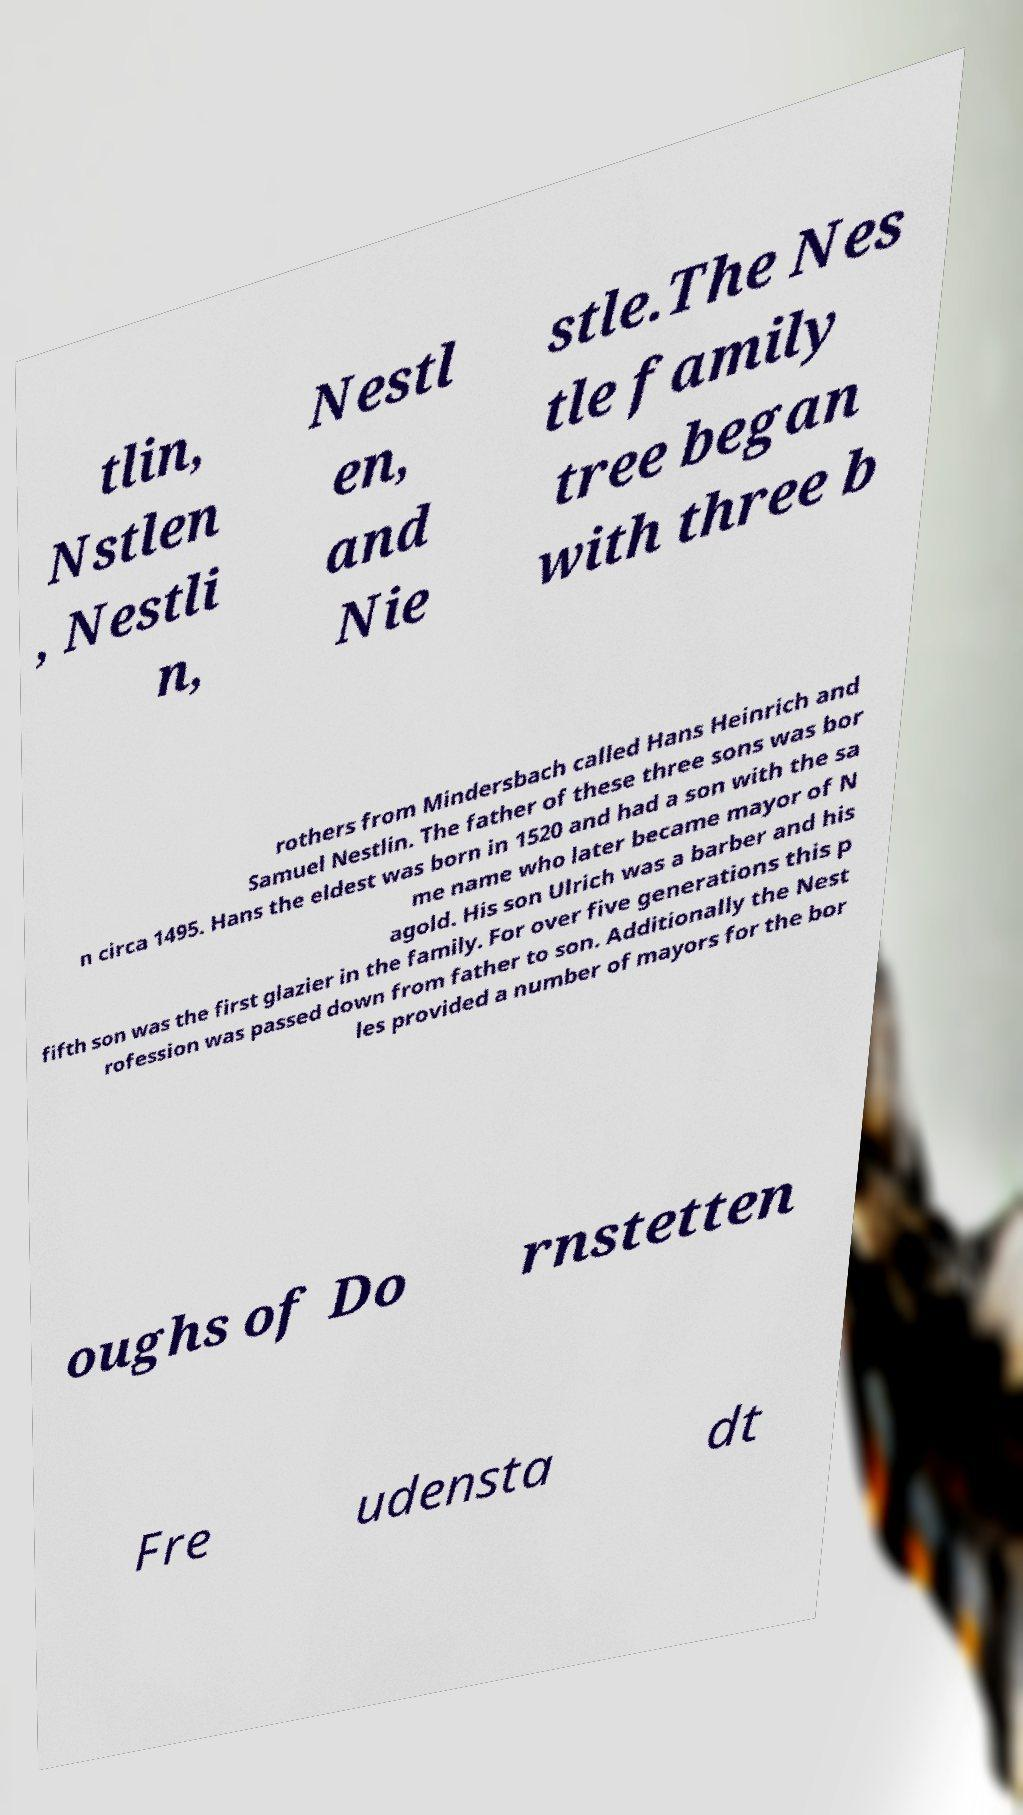What messages or text are displayed in this image? I need them in a readable, typed format. tlin, Nstlen , Nestli n, Nestl en, and Nie stle.The Nes tle family tree began with three b rothers from Mindersbach called Hans Heinrich and Samuel Nestlin. The father of these three sons was bor n circa 1495. Hans the eldest was born in 1520 and had a son with the sa me name who later became mayor of N agold. His son Ulrich was a barber and his fifth son was the first glazier in the family. For over five generations this p rofession was passed down from father to son. Additionally the Nest les provided a number of mayors for the bor oughs of Do rnstetten Fre udensta dt 